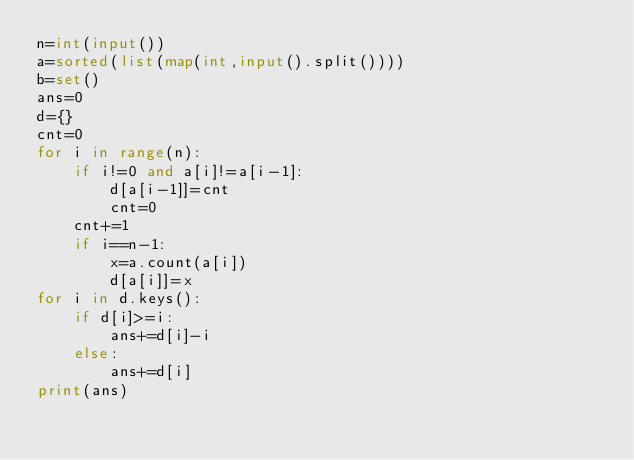Convert code to text. <code><loc_0><loc_0><loc_500><loc_500><_Python_>n=int(input())
a=sorted(list(map(int,input().split())))
b=set()
ans=0
d={}
cnt=0
for i in range(n):
    if i!=0 and a[i]!=a[i-1]:
        d[a[i-1]]=cnt
        cnt=0
    cnt+=1
    if i==n-1:
        x=a.count(a[i])
        d[a[i]]=x
for i in d.keys():
    if d[i]>=i:
        ans+=d[i]-i
    else:
        ans+=d[i]
print(ans)</code> 